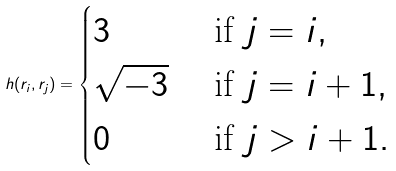Convert formula to latex. <formula><loc_0><loc_0><loc_500><loc_500>h ( r _ { i } , r _ { j } ) = \begin{cases} 3 & \text { if } j = i , \\ \sqrt { - 3 } & \text { if } j = i + 1 , \\ 0 & \text { if } j > i + 1 . \end{cases}</formula> 